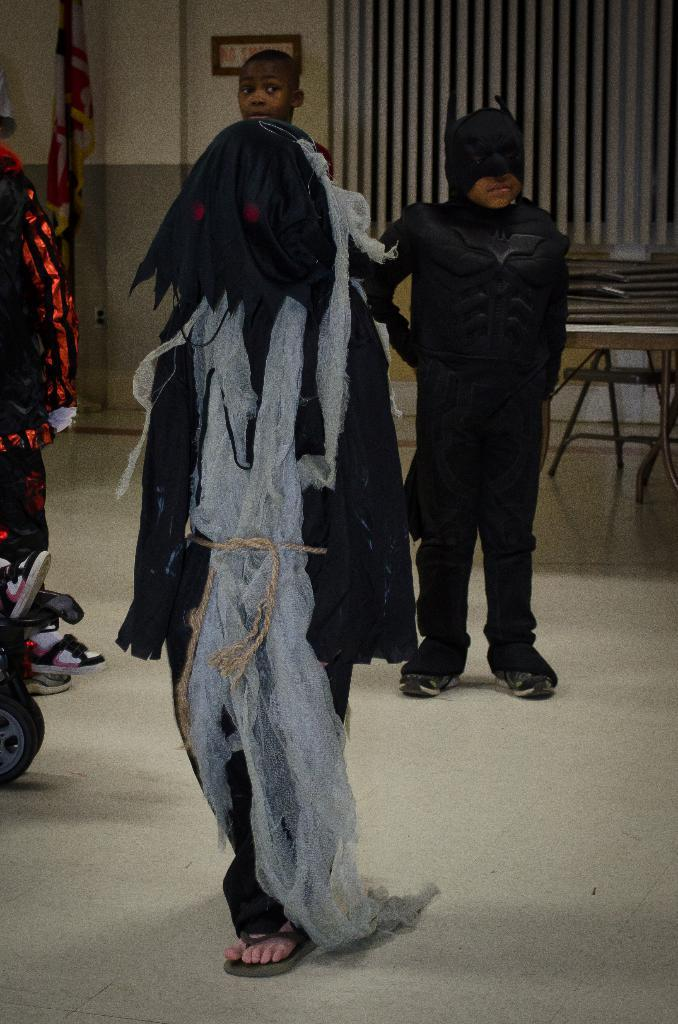What can be seen in the image? There are people standing in the image. What is located behind the people? There is a table behind the people. What is at the top of the image? There is a wall at the top of the image. What objects are present in the image? There is a pole and a flag in the image. What type of silk is being used to make the dolls in the image? There are no dolls or silk present in the image. 